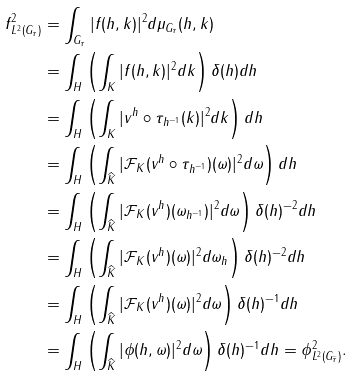<formula> <loc_0><loc_0><loc_500><loc_500>\| f \| _ { L ^ { 2 } ( G _ { \tau } ) } ^ { 2 } & = \int _ { G _ { \tau } } | f ( h , k ) | ^ { 2 } d \mu _ { G _ { \tau } } ( h , k ) \\ & = \int _ { H } \left ( \int _ { K } | f ( h , k ) | ^ { 2 } d k \right ) \delta ( h ) d h \\ & = \int _ { H } \left ( \int _ { K } | v ^ { h } \circ \tau _ { h ^ { - 1 } } ( k ) | ^ { 2 } d k \right ) d h \\ & = \int _ { H } \left ( \int _ { \widehat { K } } | \mathcal { F } _ { K } ( v ^ { h } \circ \tau _ { h ^ { - 1 } } ) ( \omega ) | ^ { 2 } d \omega \right ) d h \\ & = \int _ { H } \left ( \int _ { \widehat { K } } | \mathcal { F } _ { K } ( v ^ { h } ) ( \omega _ { h ^ { - 1 } } ) | ^ { 2 } d \omega \right ) \delta ( h ) ^ { - 2 } d h \\ & = \int _ { H } \left ( \int _ { \widehat { K } } | \mathcal { F } _ { K } ( v ^ { h } ) ( \omega ) | ^ { 2 } d \omega _ { h } \right ) \delta ( h ) ^ { - 2 } d h \\ & = \int _ { H } \left ( \int _ { \widehat { K } } | \mathcal { F } _ { K } ( v ^ { h } ) ( \omega ) | ^ { 2 } d \omega \right ) \delta ( h ) ^ { - 1 } d h \\ & = \int _ { H } \left ( \int _ { \widehat { K } } | \phi ( h , \omega ) | ^ { 2 } d \omega \right ) \delta ( h ) ^ { - 1 } d h = \| \phi \| ^ { 2 } _ { L ^ { 2 } ( G _ { \widehat { \tau } } ) } .</formula> 